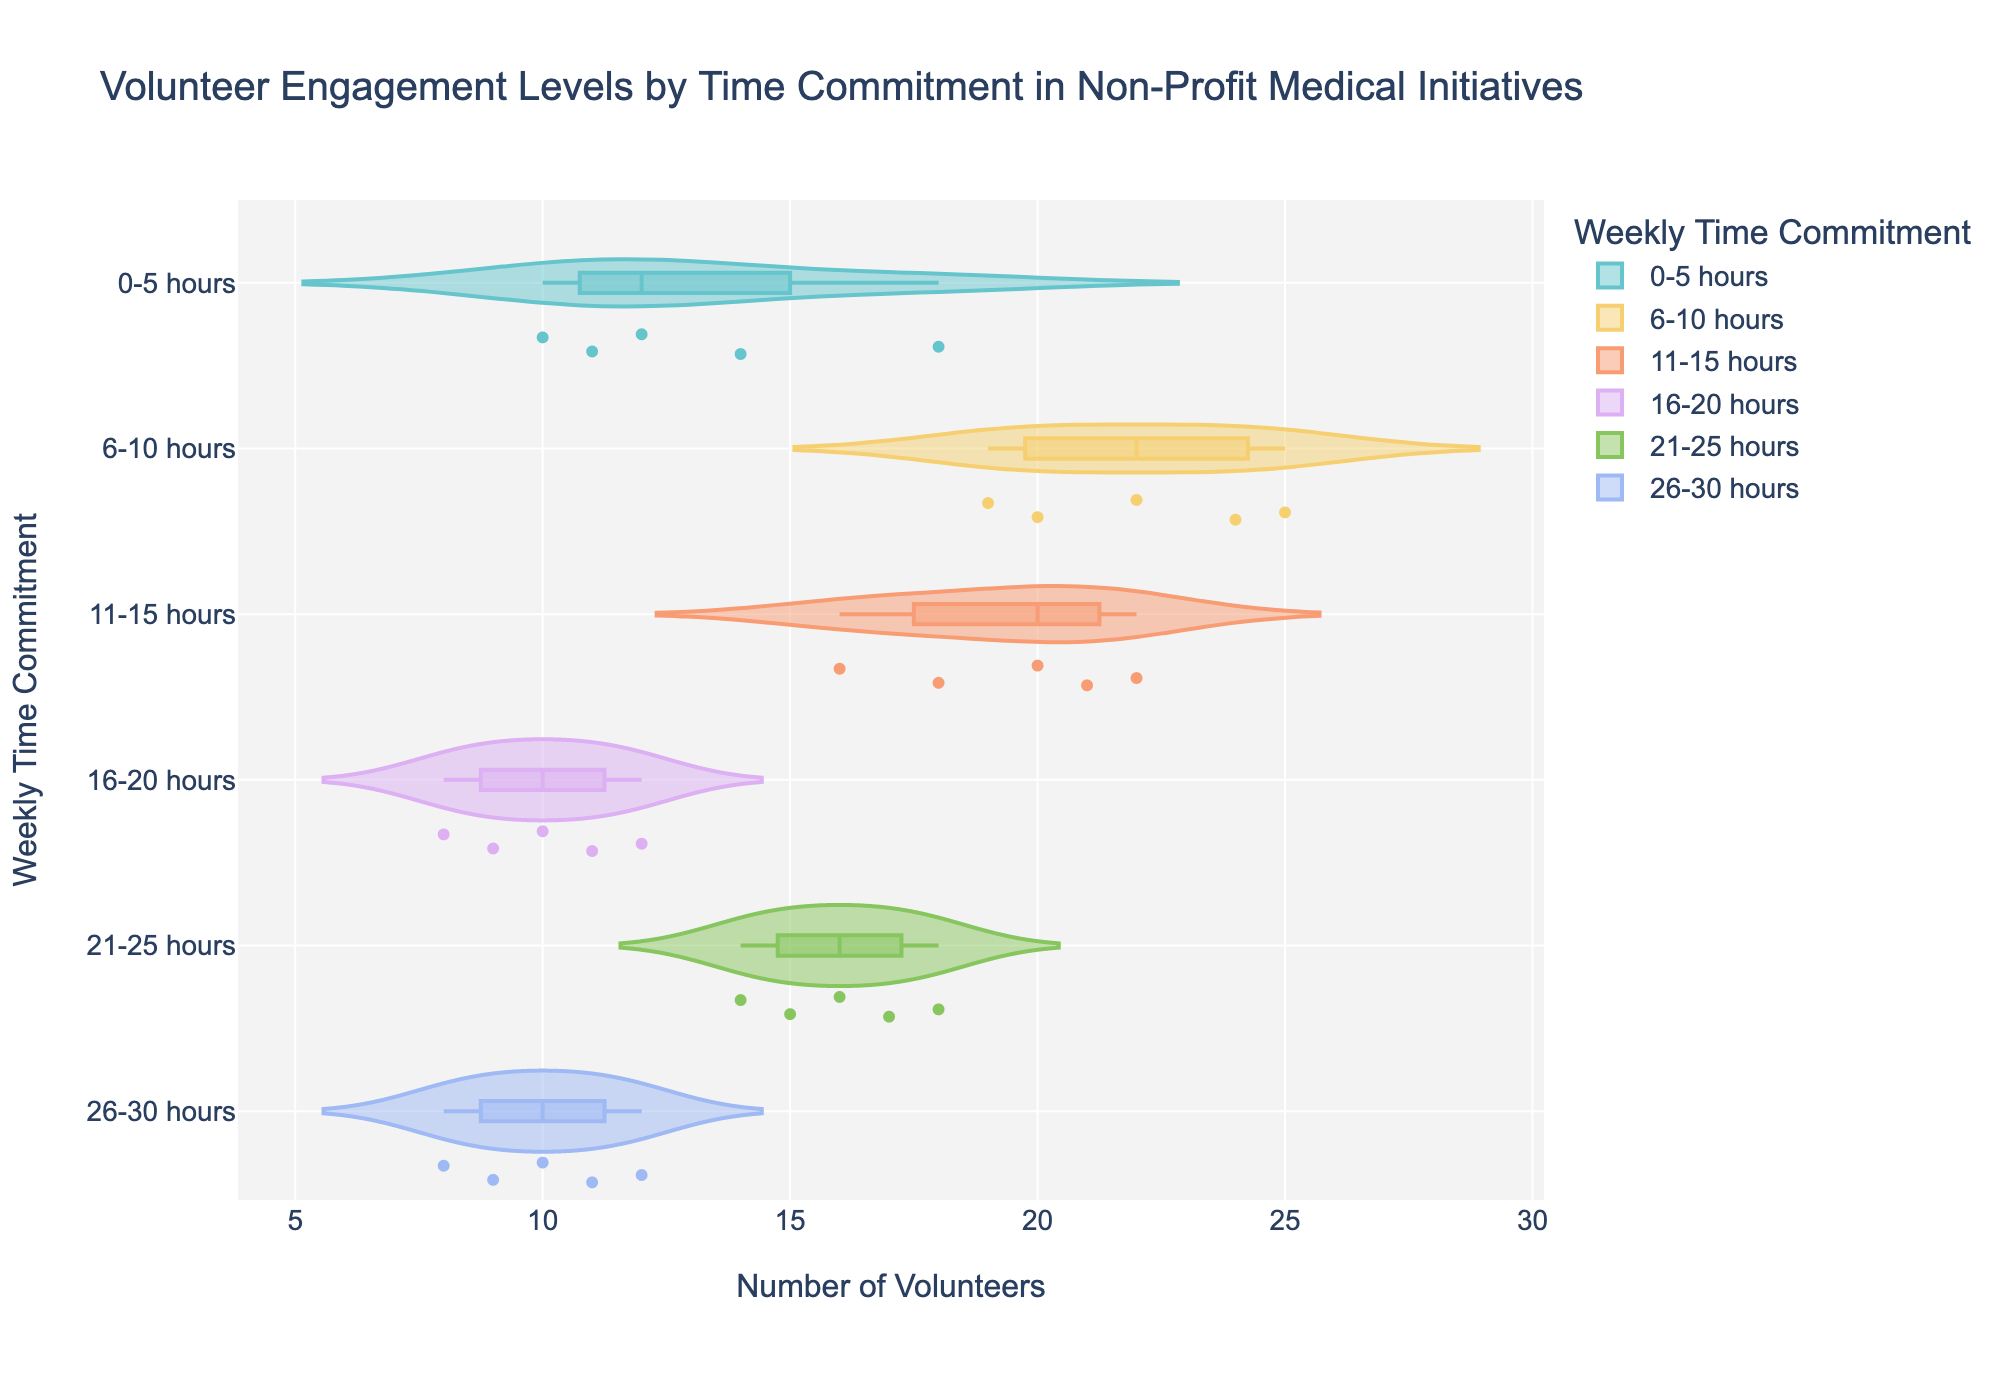What is the title of the chart? The title is usually displayed prominently at the top of the chart and provides an overview of what the chart is about. Read the text at the top to find the title.
Answer: Volunteer Engagement Levels by Time Commitment in Non-Profit Medical Initiatives How are the time commitments color-coded in the chart? Look at the legend or the colored boxes next to the categories on the y-axis to see the corresponding colors for each time commitment.
Answer: In pastel colors Which time commitment category has the highest median number of volunteers? Check the median line inside the boxplot for each time commitment category. The category with the highest median line represents the highest median number of volunteers.
Answer: 6-10 hours What is the range of volunteers for the 16-20 hours time commitment category? Look at the spread of points and the vertical extent of the violin plot for the 16-20 hours category to find the minimum and maximum values.
Answer: 8 to 12 How does the distribution of volunteers for 0-5 hours compare to that of 26-30 hours? Observe the shape, spread, and median lines of the violin plots for both categories. Compare their widths and where the bulk of the data points lie.
Answer: 0-5 hours has a wider and higher distribution compared to 26-30 hours Which time commitment category shows the most variability in the number of volunteers? Look at the width and spread of the violin plots. The category with the widest and most spread out distribution has the most variability.
Answer: 6-10 hours What is the interquartile range (IQR) of the number of volunteers for the 21-25 hours category? The IQR is the range between the first quartile (bottom of the box) and the third quartile (top of the box) in the boxplot. Find these values for the 21-25 hours category and calculate the difference.
Answer: 14 to 18 Which time commitment has the lowest maximum number of volunteers? Check each category's highest point in the violin plot to determine the maximum number of volunteers. Identify the smallest maximum value across categories.
Answer: 16-20 hours Are there any outliers in the data for the 11-15 hours category? Look for any individual points shown outside of the main bulk of the violin plot for the 11-15 hours category. These points typically represent outliers.
Answer: No What can you say about the distribution of volunteers in the 21-25 hours category compared to 11-15 hours? Compare the shapes, widths, and median lines of the violin plots for the 21-25 hours and 11-15 hours categories to understand the differences in distribution and central tendency.
Answer: 21-25 hours has a slightly more dispersed distribution with a lower median 